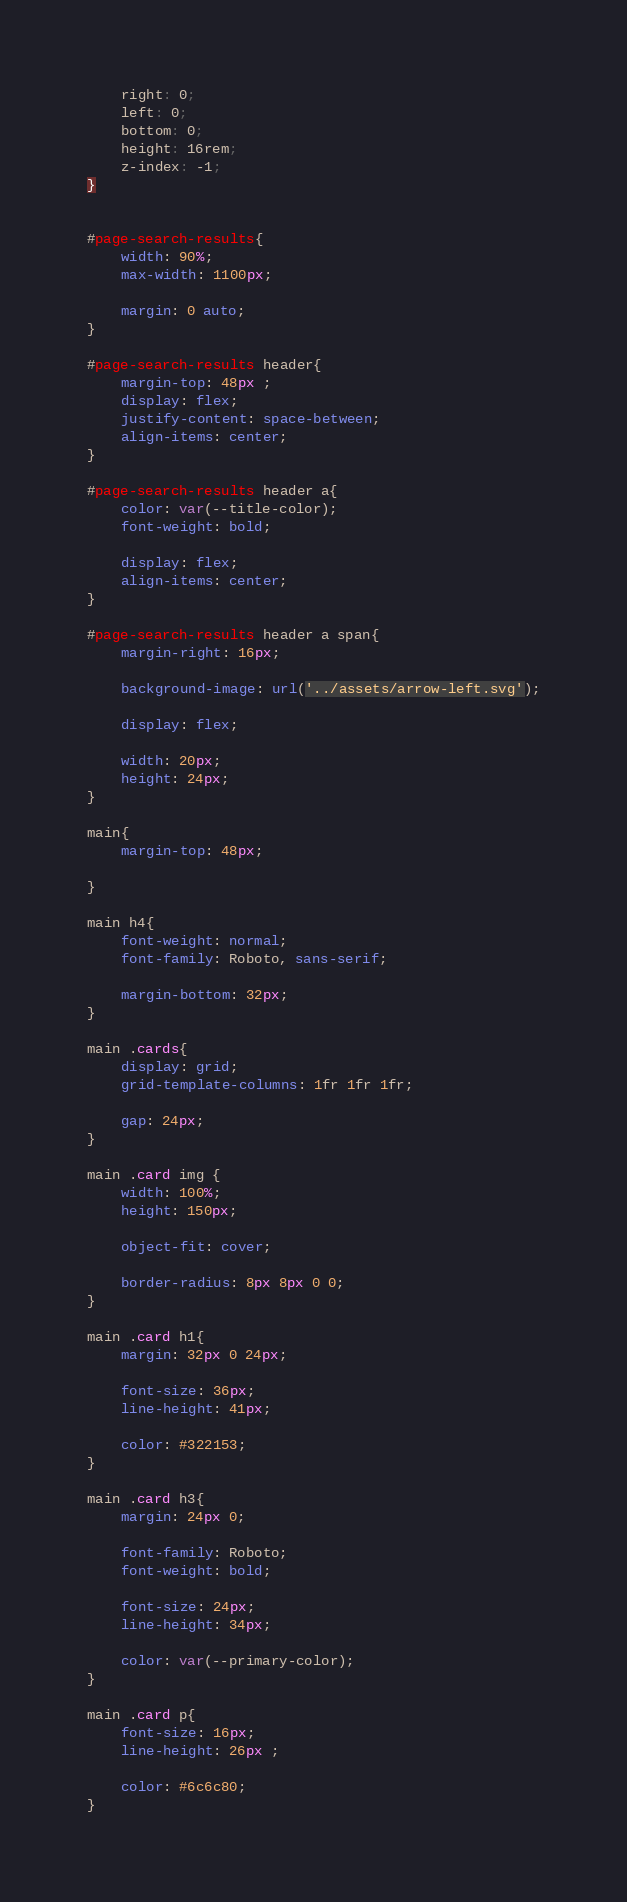<code> <loc_0><loc_0><loc_500><loc_500><_CSS_>    right: 0;
    left: 0;
    bottom: 0;
    height: 16rem;
    z-index: -1;
}


#page-search-results{
    width: 90%;
    max-width: 1100px;

    margin: 0 auto;
}

#page-search-results header{
    margin-top: 48px ;
    display: flex;
    justify-content: space-between;
    align-items: center;
}

#page-search-results header a{
    color: var(--title-color);
    font-weight: bold;

    display: flex;
    align-items: center;
}

#page-search-results header a span{
    margin-right: 16px;

    background-image: url('../assets/arrow-left.svg');
    
    display: flex;

    width: 20px;
    height: 24px;
}

main{
    margin-top: 48px;

}

main h4{
    font-weight: normal;
    font-family: Roboto, sans-serif;

    margin-bottom: 32px;
}

main .cards{
    display: grid;
    grid-template-columns: 1fr 1fr 1fr;

    gap: 24px;
}

main .card img {
    width: 100%;
    height: 150px;

    object-fit: cover;

    border-radius: 8px 8px 0 0;
}

main .card h1{
    margin: 32px 0 24px;

    font-size: 36px;
    line-height: 41px;

    color: #322153;
}

main .card h3{
    margin: 24px 0;

    font-family: Roboto;
    font-weight: bold;

    font-size: 24px;
    line-height: 34px;

    color: var(--primary-color);
}

main .card p{
    font-size: 16px;
    line-height: 26px ;

    color: #6c6c80;
}</code> 